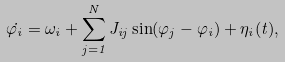Convert formula to latex. <formula><loc_0><loc_0><loc_500><loc_500>\dot { \varphi _ { i } } = \omega _ { i } + \sum _ { j = 1 } ^ { N } J _ { i j } \sin ( \varphi _ { j } - \varphi _ { i } ) + \eta _ { i } ( t ) ,</formula> 